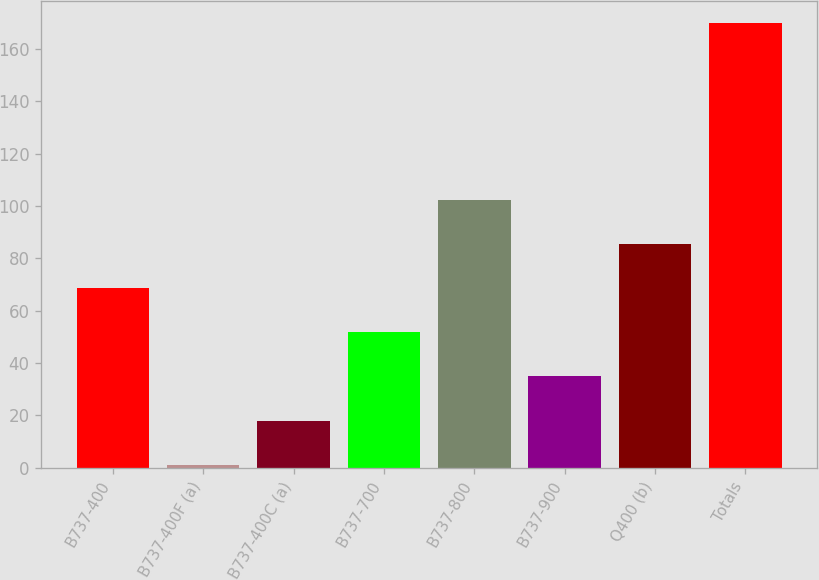<chart> <loc_0><loc_0><loc_500><loc_500><bar_chart><fcel>B737-400<fcel>B737-400F (a)<fcel>B737-400C (a)<fcel>B737-700<fcel>B737-800<fcel>B737-900<fcel>Q400 (b)<fcel>Totals<nl><fcel>68.6<fcel>1<fcel>17.9<fcel>51.7<fcel>102.4<fcel>34.8<fcel>85.5<fcel>170<nl></chart> 